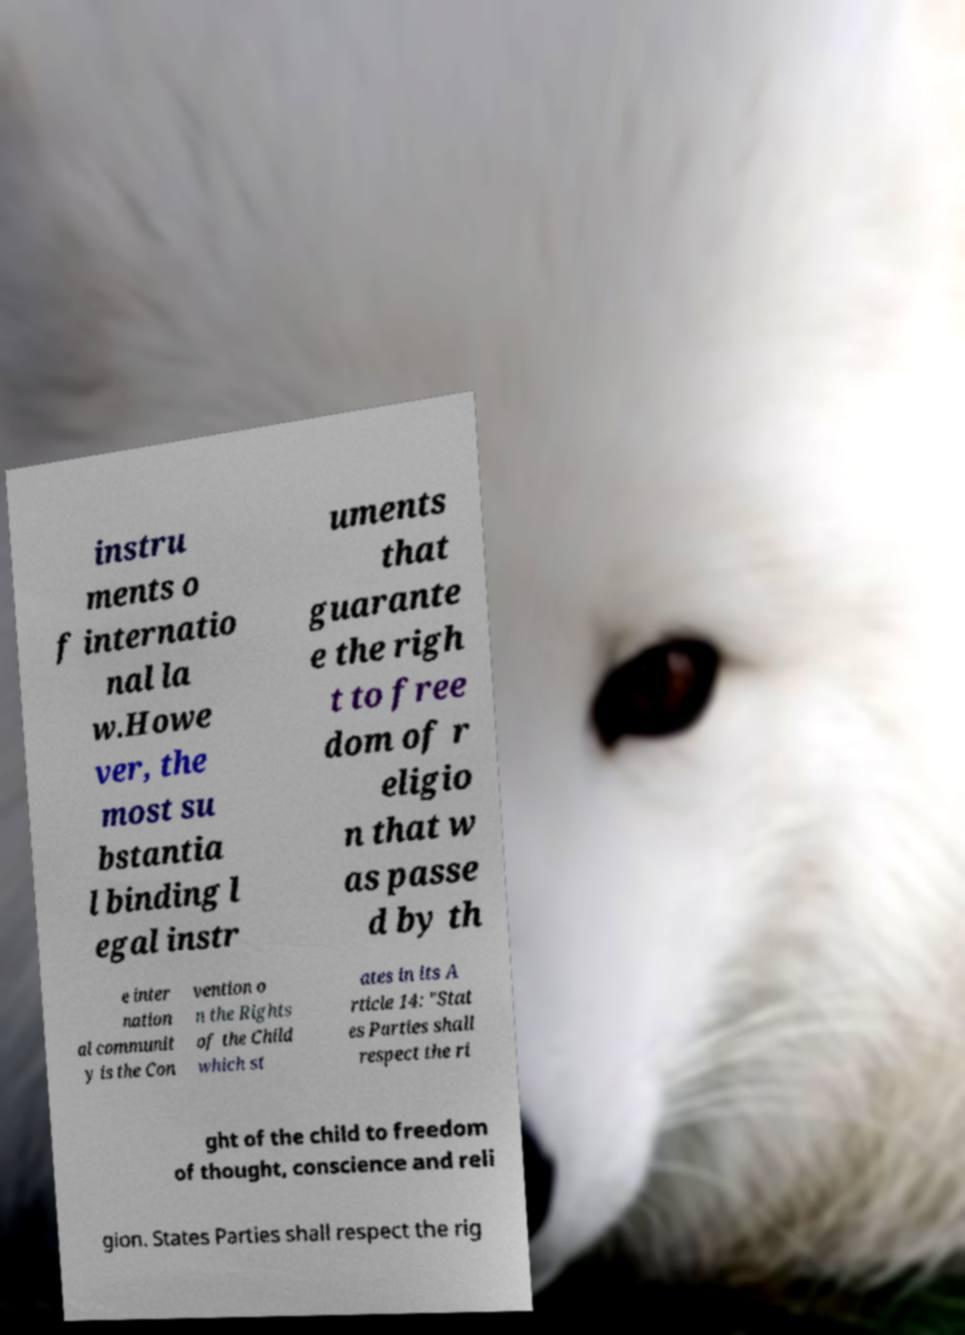Could you extract and type out the text from this image? instru ments o f internatio nal la w.Howe ver, the most su bstantia l binding l egal instr uments that guarante e the righ t to free dom of r eligio n that w as passe d by th e inter nation al communit y is the Con vention o n the Rights of the Child which st ates in its A rticle 14: "Stat es Parties shall respect the ri ght of the child to freedom of thought, conscience and reli gion. States Parties shall respect the rig 